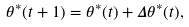Convert formula to latex. <formula><loc_0><loc_0><loc_500><loc_500>\theta ^ { * } ( t + 1 ) = \theta ^ { * } ( t ) + \Delta \theta ^ { * } ( t ) ,</formula> 